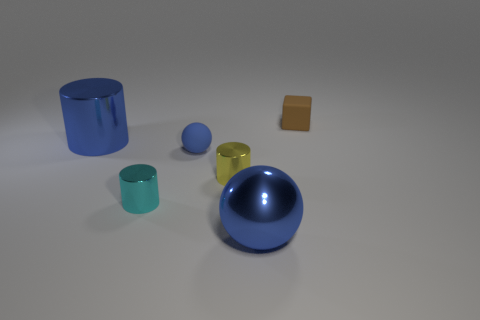There is another tiny shiny thing that is the same shape as the yellow thing; what color is it?
Make the answer very short. Cyan. Is there any other thing that has the same shape as the cyan thing?
Your answer should be compact. Yes. Are there an equal number of large metal things to the right of the large blue metallic cylinder and small blue rubber things?
Your answer should be very brief. Yes. How many things are both in front of the cyan metal cylinder and behind the large shiny cylinder?
Your answer should be compact. 0. There is a blue metal thing that is the same shape as the yellow object; what is its size?
Provide a short and direct response. Large. What number of small blue spheres have the same material as the yellow cylinder?
Ensure brevity in your answer.  0. Is the number of rubber spheres to the left of the small blue rubber sphere less than the number of small balls?
Your answer should be compact. Yes. What number of cyan metal cylinders are there?
Make the answer very short. 1. How many small things have the same color as the matte cube?
Your response must be concise. 0. Do the small blue rubber thing and the small cyan metal object have the same shape?
Give a very brief answer. No. 